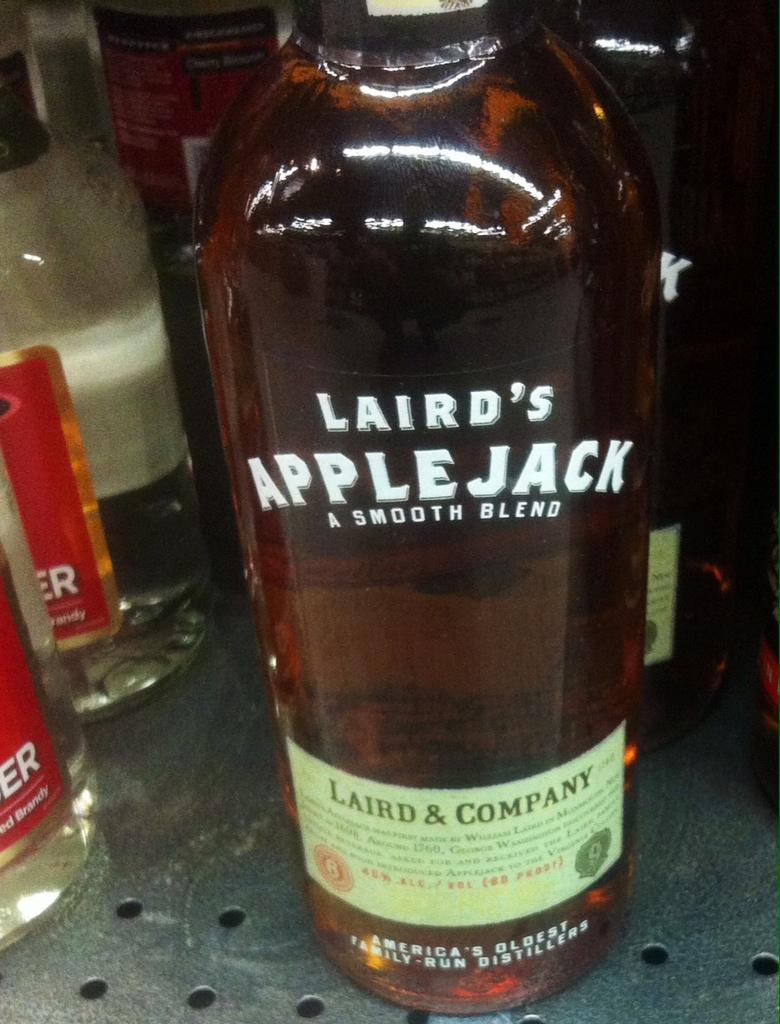In one or two sentences, can you explain what this image depicts? These are bottles. 